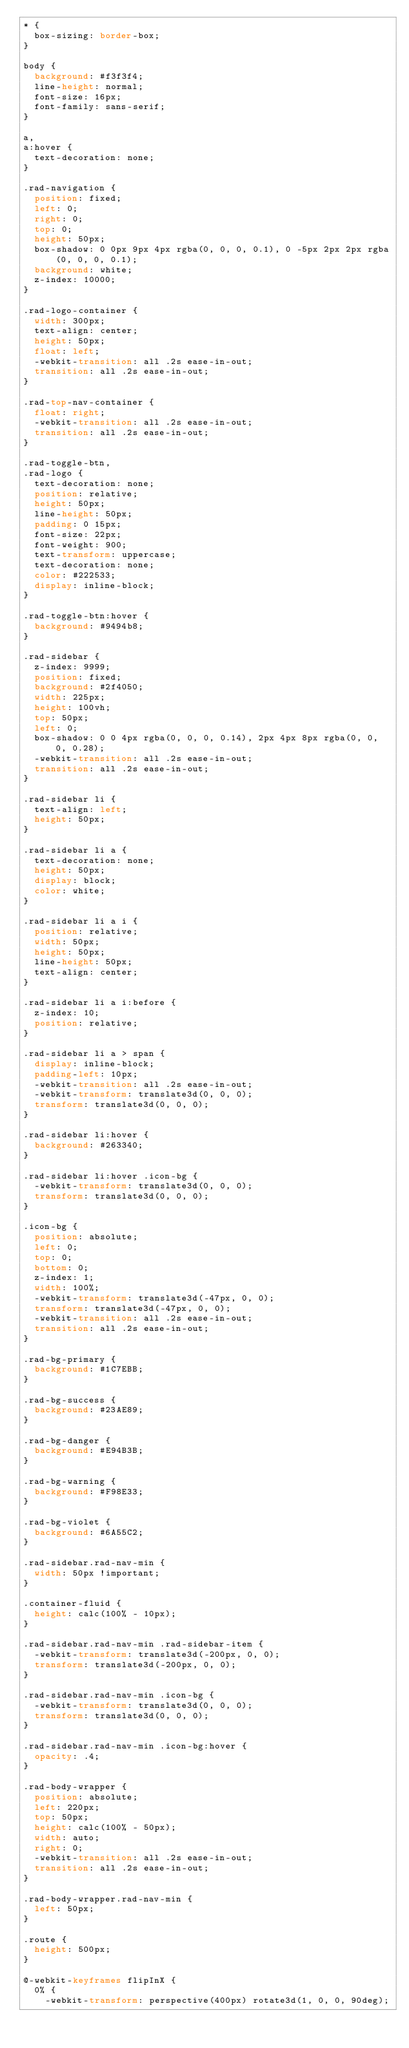<code> <loc_0><loc_0><loc_500><loc_500><_CSS_>* {
  box-sizing: border-box;
}

body {
  background: #f3f3f4;
  line-height: normal;
  font-size: 16px;
  font-family: sans-serif;
}

a,
a:hover {
  text-decoration: none;
}

.rad-navigation {
  position: fixed;
  left: 0;
  right: 0;
  top: 0;
  height: 50px;
  box-shadow: 0 0px 9px 4px rgba(0, 0, 0, 0.1), 0 -5px 2px 2px rgba(0, 0, 0, 0.1);
  background: white;
  z-index: 10000;
}

.rad-logo-container {
  width: 300px;
  text-align: center;
  height: 50px;
  float: left;
  -webkit-transition: all .2s ease-in-out;
  transition: all .2s ease-in-out;
}

.rad-top-nav-container {
  float: right;
  -webkit-transition: all .2s ease-in-out;
  transition: all .2s ease-in-out;
}

.rad-toggle-btn,
.rad-logo {
  text-decoration: none;
  position: relative;
  height: 50px;
  line-height: 50px;
  padding: 0 15px;
  font-size: 22px;
  font-weight: 900;
  text-transform: uppercase;
  text-decoration: none;
  color: #222533;
  display: inline-block;
}

.rad-toggle-btn:hover {
  background: #9494b8;
}

.rad-sidebar {
  z-index: 9999;
  position: fixed;
  background: #2f4050;
  width: 225px;
  height: 100vh;
  top: 50px;
  left: 0;
  box-shadow: 0 0 4px rgba(0, 0, 0, 0.14), 2px 4px 8px rgba(0, 0, 0, 0.28);
  -webkit-transition: all .2s ease-in-out;
  transition: all .2s ease-in-out;
}

.rad-sidebar li {
  text-align: left;
  height: 50px;
}

.rad-sidebar li a {
  text-decoration: none;
  height: 50px;
  display: block;
  color: white;
}

.rad-sidebar li a i {
  position: relative;
  width: 50px;
  height: 50px;
  line-height: 50px;
  text-align: center;
}

.rad-sidebar li a i:before {
  z-index: 10;
  position: relative;
}

.rad-sidebar li a > span {
  display: inline-block;
  padding-left: 10px;
  -webkit-transition: all .2s ease-in-out;
  -webkit-transform: translate3d(0, 0, 0);
  transform: translate3d(0, 0, 0);
}

.rad-sidebar li:hover {
  background: #263340;
}

.rad-sidebar li:hover .icon-bg {
  -webkit-transform: translate3d(0, 0, 0);
  transform: translate3d(0, 0, 0);
}

.icon-bg {
  position: absolute;
  left: 0;
  top: 0;
  bottom: 0;
  z-index: 1;
  width: 100%;
  -webkit-transform: translate3d(-47px, 0, 0);
  transform: translate3d(-47px, 0, 0);
  -webkit-transition: all .2s ease-in-out;
  transition: all .2s ease-in-out;
}

.rad-bg-primary {
  background: #1C7EBB;
}

.rad-bg-success {
  background: #23AE89;
}

.rad-bg-danger {
  background: #E94B3B;
}

.rad-bg-warning {
  background: #F98E33;
}

.rad-bg-violet {
  background: #6A55C2;
}

.rad-sidebar.rad-nav-min {
  width: 50px !important;
}

.container-fluid {
  height: calc(100% - 10px);
}

.rad-sidebar.rad-nav-min .rad-sidebar-item {
  -webkit-transform: translate3d(-200px, 0, 0);
  transform: translate3d(-200px, 0, 0);
}

.rad-sidebar.rad-nav-min .icon-bg {
  -webkit-transform: translate3d(0, 0, 0);
  transform: translate3d(0, 0, 0);
}

.rad-sidebar.rad-nav-min .icon-bg:hover {
  opacity: .4;
}

.rad-body-wrapper {
  position: absolute;
  left: 220px;
  top: 50px;
  height: calc(100% - 50px);
  width: auto;
  right: 0;
  -webkit-transition: all .2s ease-in-out;
  transition: all .2s ease-in-out;
}

.rad-body-wrapper.rad-nav-min {
  left: 50px;
}

.route {
  height: 500px;
}

@-webkit-keyframes flipInX {
  0% {
    -webkit-transform: perspective(400px) rotate3d(1, 0, 0, 90deg);</code> 